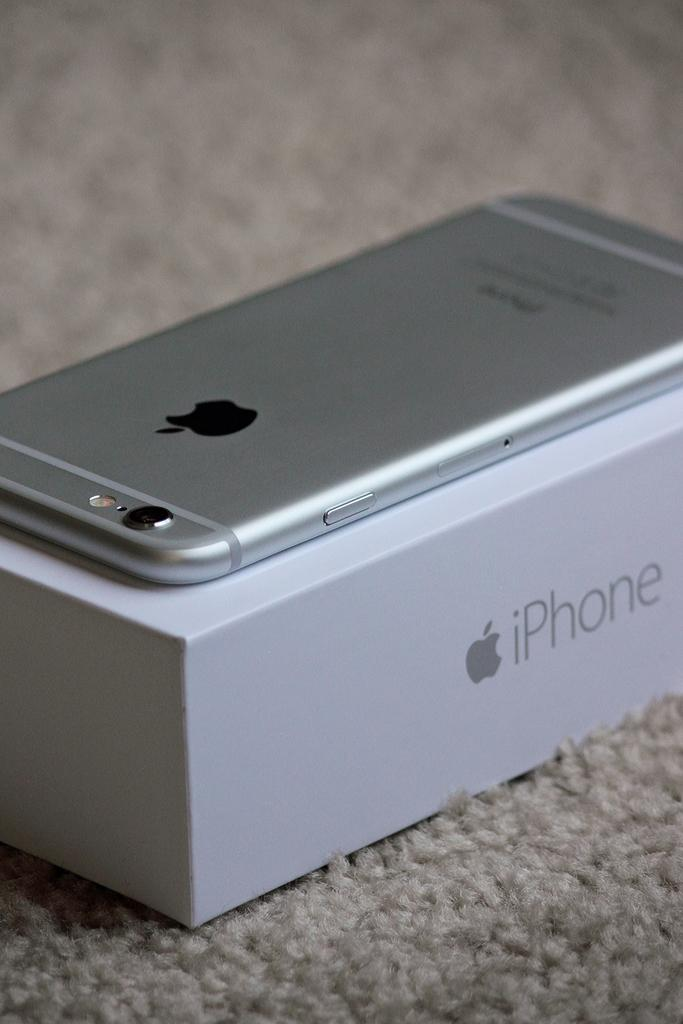<image>
Create a compact narrative representing the image presented. A silver iPhone laying upside down on top of the box it came in. 